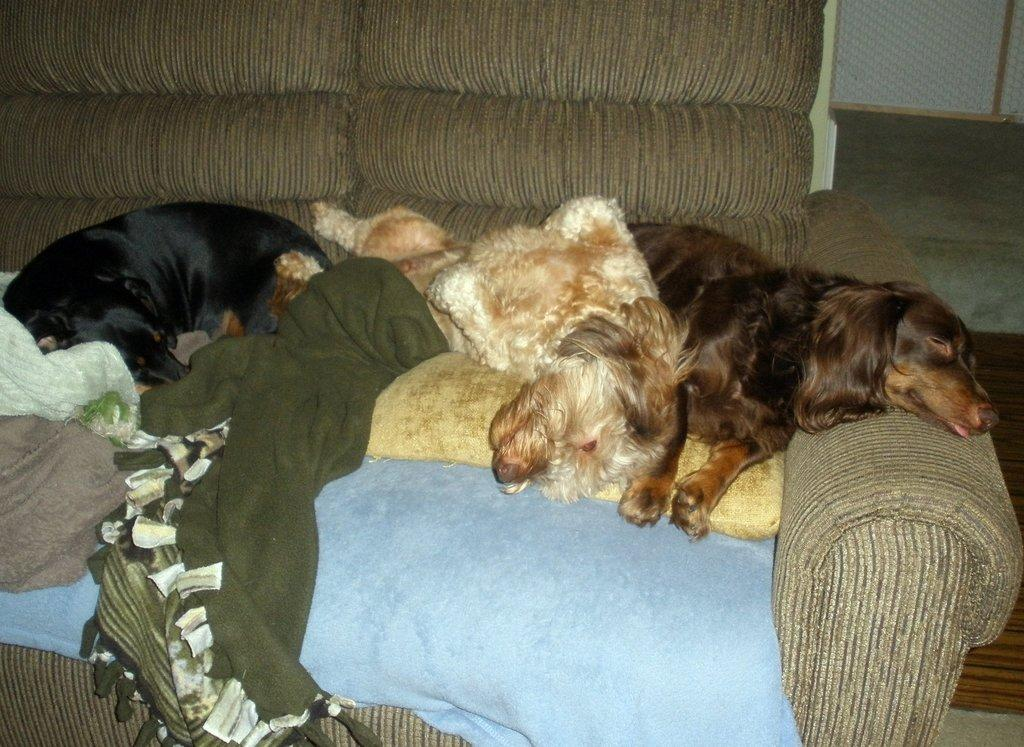What animals are present in the image? There is a group of dogs in the image. What are the dogs doing in the image? The dogs are lying on a sofa. Where is the sofa located in the image? The sofa is present over a place. What type of clover is being served by the dogs in the image? There is no clover or servant present in the image; it features a group of dogs lying on a sofa. What is the relationship between the dogs and the aunt in the image? There is no aunt present in the image; it features a group of dogs lying on a sofa. 